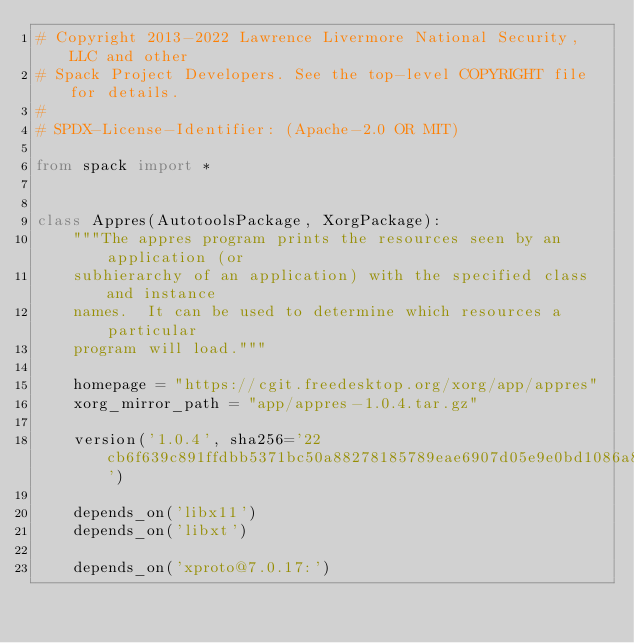<code> <loc_0><loc_0><loc_500><loc_500><_Python_># Copyright 2013-2022 Lawrence Livermore National Security, LLC and other
# Spack Project Developers. See the top-level COPYRIGHT file for details.
#
# SPDX-License-Identifier: (Apache-2.0 OR MIT)

from spack import *


class Appres(AutotoolsPackage, XorgPackage):
    """The appres program prints the resources seen by an application (or
    subhierarchy of an application) with the specified class and instance
    names.  It can be used to determine which resources a particular
    program will load."""

    homepage = "https://cgit.freedesktop.org/xorg/app/appres"
    xorg_mirror_path = "app/appres-1.0.4.tar.gz"

    version('1.0.4', sha256='22cb6f639c891ffdbb5371bc50a88278185789eae6907d05e9e0bd1086a80803')

    depends_on('libx11')
    depends_on('libxt')

    depends_on('xproto@7.0.17:')</code> 